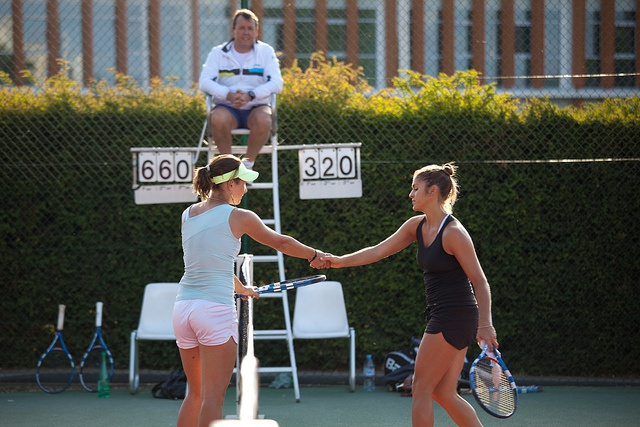Describe the objects in this image and their specific colors. I can see people in gray, brown, darkgray, and black tones, people in gray, black, and brown tones, people in gray, brown, lavender, and darkgray tones, chair in gray, lightblue, and darkgray tones, and chair in gray, lightblue, black, and purple tones in this image. 